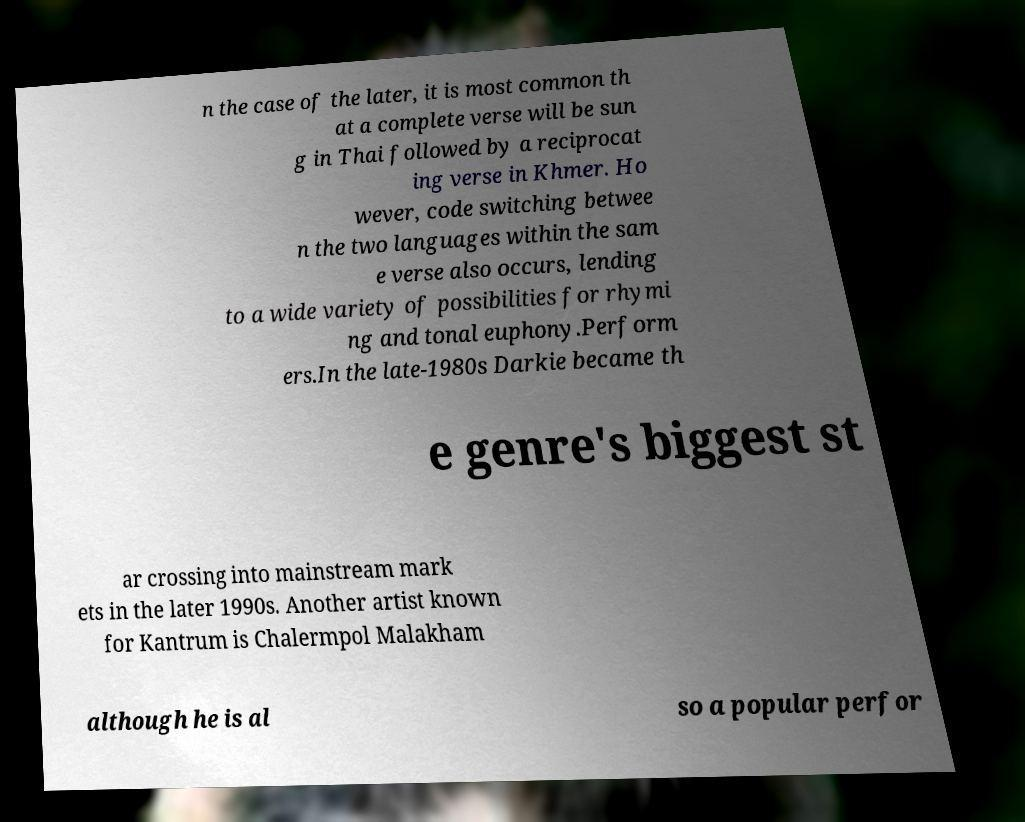There's text embedded in this image that I need extracted. Can you transcribe it verbatim? n the case of the later, it is most common th at a complete verse will be sun g in Thai followed by a reciprocat ing verse in Khmer. Ho wever, code switching betwee n the two languages within the sam e verse also occurs, lending to a wide variety of possibilities for rhymi ng and tonal euphony.Perform ers.In the late-1980s Darkie became th e genre's biggest st ar crossing into mainstream mark ets in the later 1990s. Another artist known for Kantrum is Chalermpol Malakham although he is al so a popular perfor 